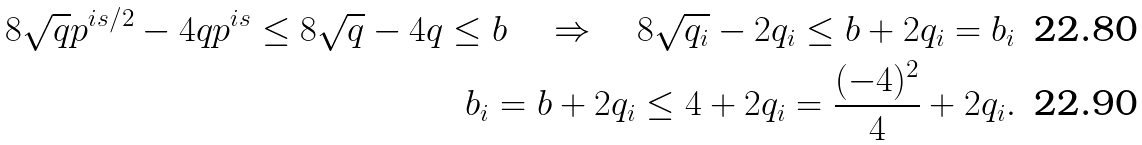<formula> <loc_0><loc_0><loc_500><loc_500>8 \sqrt { q } p ^ { i s / 2 } - 4 q p ^ { i s } \leq 8 \sqrt { q } - 4 q \leq b \quad \Rightarrow \quad 8 \sqrt { q _ { i } } - 2 q _ { i } \leq b + 2 q _ { i } = b _ { i } \\ b _ { i } = b + 2 q _ { i } \leq 4 + 2 q _ { i } = \frac { ( - 4 ) ^ { 2 } } { 4 } + 2 q _ { i } .</formula> 